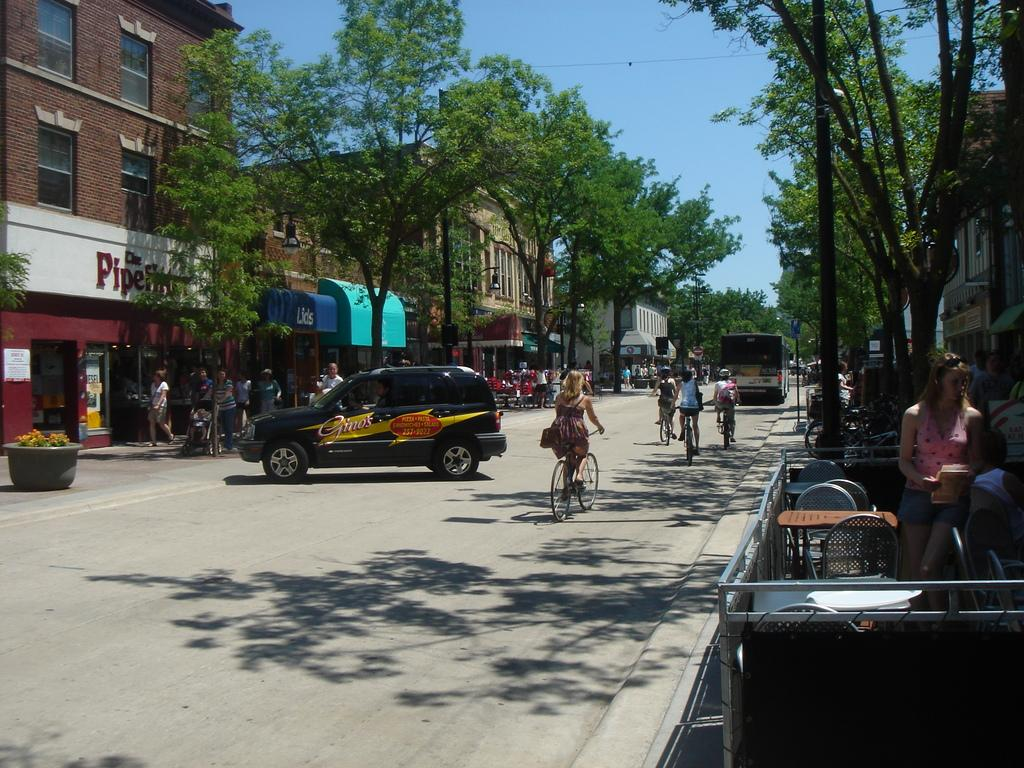<image>
Summarize the visual content of the image. A street scene and a shope with the word Pine is visible on the left. 